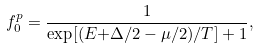<formula> <loc_0><loc_0><loc_500><loc_500>f _ { 0 } ^ { p } = { \frac { 1 } { { \exp [ ( } E { + \Delta / 2 - \mu / 2 ) / T ] + 1 } } } ,</formula> 